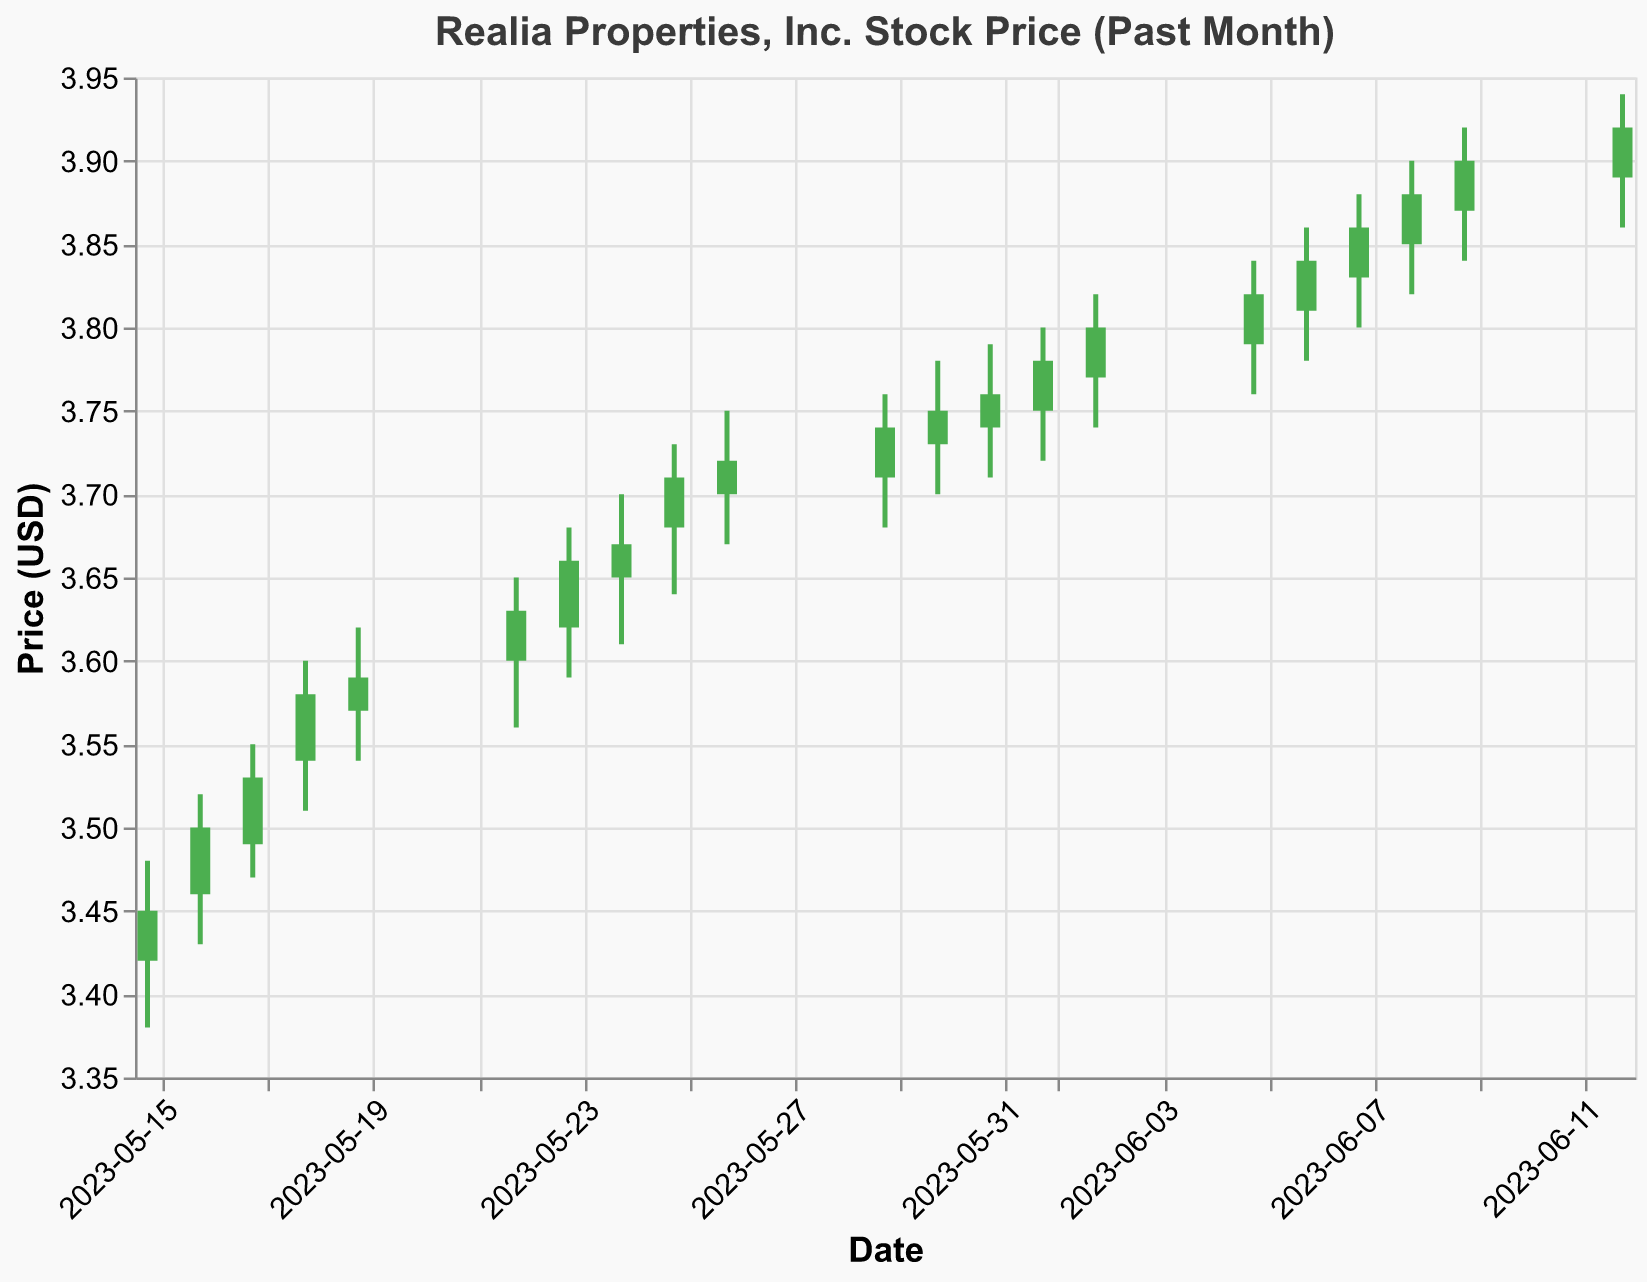What is the title of the chart? The title can be found at the top of the chart, formatted in a bold and larger font size compared to other text elements. It reads "Realia Properties, Inc. Stock Price (Past Month)".
Answer: Realia Properties, Inc. Stock Price (Past Month) How many data points are shown on the chart? The number of data points corresponds to the number of rows in the data table, which indicates the number of days represented on the chart. By counting the entries in the dataset, we see there are 20 data points.
Answer: 20 What was the highest closing price in the past month? The highest closing price can be found by comparing the "Close" values for each date. The maximum "Close" value in the dataset is 3.92, which occurred on June 12, 2023.
Answer: 3.92 On which date did the lowest opening price occur? To find the lowest opening price, we assess the "Open" values. The lowest opening value in the dataset is 3.42, which corresponds to May 15, 2023.
Answer: May 15, 2023 How did the stock price change from May 15 to June 12? To determine the change in stock price, we compare the "Close" value on May 15 (3.45) with the "Close" value on June 12 (3.92). The difference is calculated as 3.92 - 3.45, which is 0.47.
Answer: Increased by 0.47 Which day had the highest trading volume, and what was the volume? From the dataset, we compare the "Volume" for each day. The highest trading volume is 143200, which occurred on May 18, 2023.
Answer: May 18, 2023, 143200 Does the stock price generally show an increasing or decreasing trend over the past month? Observing the "Close" prices over the dates, we can see a general upward trend. The stock price started at 3.45 on May 15 and closed at 3.92 on June 12, showing a net increase.
Answer: Increasing Which days had a closing price higher than their opening price? By comparing "Close" and "Open" values for each date, we identify the days where the closing price is higher. These days include May 15, May 16, May 17, May 18, May 19, May 22, May 23, May 24, May 25, May 26, May 29, May 30, May 31, June 1, June 2, June 5, June 6, June 7, June 8, June 9, and June 12.
Answer: All days except May 22, May 24, June 7 What's the range between the highest high and lowest low prices in the dataset? To find the range, we take the highest "High" value (3.94 on June 12) and subtract the lowest "Low" value (3.38 on May 15). The range is 3.94 - 3.38, which equals 0.56.
Answer: 0.56 What was the largest single-day price increase? By comparing daily "Close" and "Open" prices, we calculate the single-day increase. The largest increase was from $3.60 (Open on May 22) to $3.65 (Close on May 22), a total increase of $0.63.
Answer: 0.63 